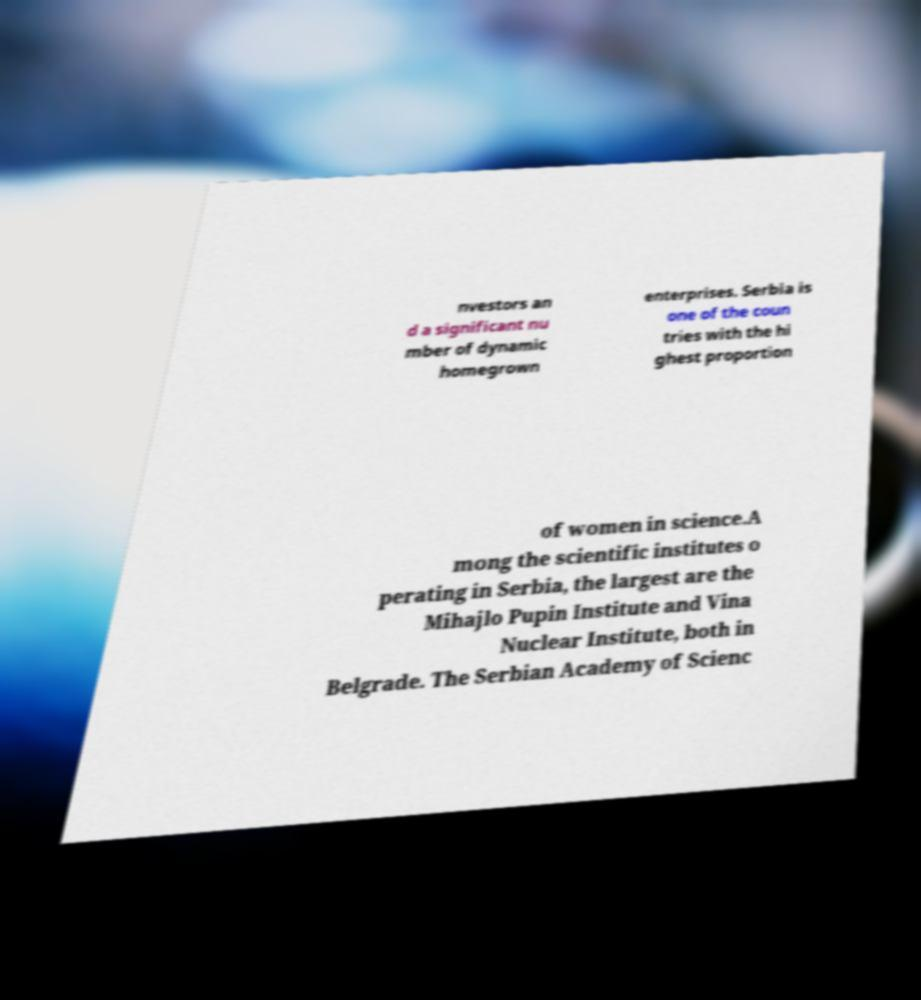Please identify and transcribe the text found in this image. nvestors an d a significant nu mber of dynamic homegrown enterprises. Serbia is one of the coun tries with the hi ghest proportion of women in science.A mong the scientific institutes o perating in Serbia, the largest are the Mihajlo Pupin Institute and Vina Nuclear Institute, both in Belgrade. The Serbian Academy of Scienc 